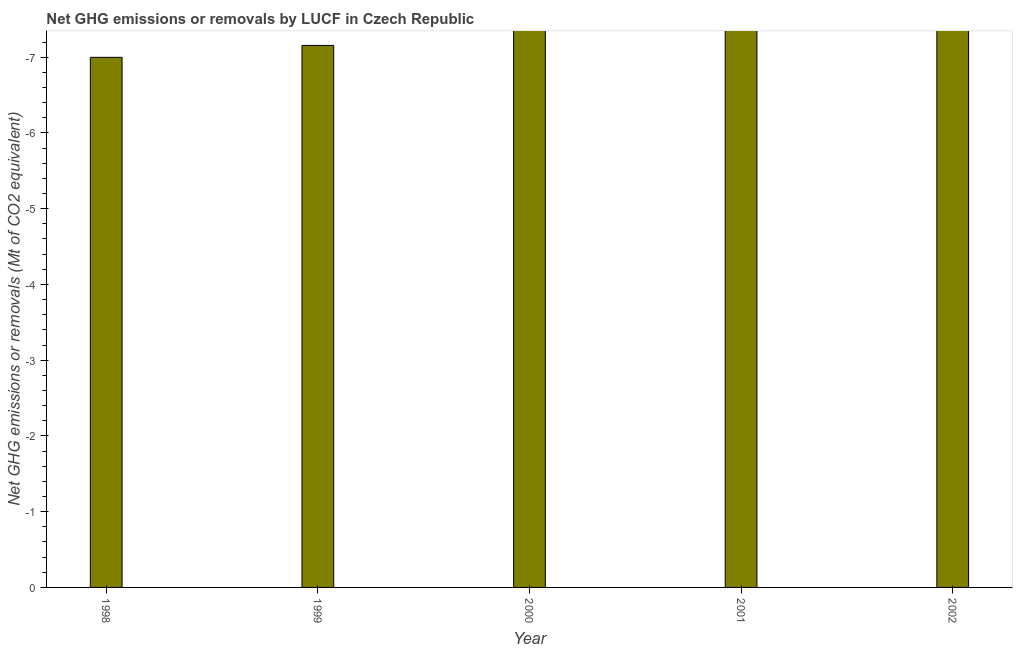Does the graph contain any zero values?
Your response must be concise. Yes. What is the title of the graph?
Provide a short and direct response. Net GHG emissions or removals by LUCF in Czech Republic. What is the label or title of the X-axis?
Ensure brevity in your answer.  Year. What is the label or title of the Y-axis?
Offer a terse response. Net GHG emissions or removals (Mt of CO2 equivalent). Across all years, what is the minimum ghg net emissions or removals?
Offer a terse response. 0. What is the sum of the ghg net emissions or removals?
Your response must be concise. 0. What is the median ghg net emissions or removals?
Give a very brief answer. 0. In how many years, is the ghg net emissions or removals greater than the average ghg net emissions or removals taken over all years?
Your answer should be compact. 0. Are all the bars in the graph horizontal?
Make the answer very short. No. What is the difference between two consecutive major ticks on the Y-axis?
Ensure brevity in your answer.  1. What is the Net GHG emissions or removals (Mt of CO2 equivalent) of 2000?
Provide a succinct answer. 0. What is the Net GHG emissions or removals (Mt of CO2 equivalent) in 2002?
Your answer should be very brief. 0. 